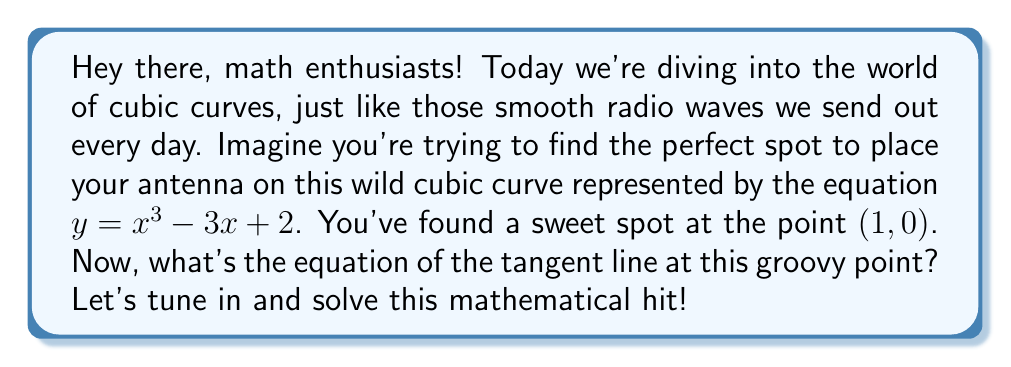Teach me how to tackle this problem. Alright, let's break this down step-by-step, just like we'd produce a killer radio show:

1) To find the equation of the tangent line, we need to use the point-slope form: $y - y_1 = m(x - x_1)$, where $(x_1, y_1)$ is our point $(1, 0)$, and $m$ is the slope of the tangent line.

2) The slope $m$ is the derivative of our curve at the point $(1, 0)$. So, let's find that derivative:

   $$\frac{dy}{dx} = 3x^2 - 3$$

3) Now, we plug in $x = 1$ to find the slope at our point:

   $$m = 3(1)^2 - 3 = 3 - 3 = 0$$

4) Surprise! Our slope is zero, which means our tangent line is horizontal. How's that for smooth sailing?

5) Now we can use the point-slope form with our point $(1, 0)$ and slope $m = 0$:

   $$y - 0 = 0(x - 1)$$

6) Simplify this equation:

   $$y = 0$$

And there you have it! Our tangent line is a horizontal line that passes through the point $(1, 0)$.
Answer: $y = 0$ 